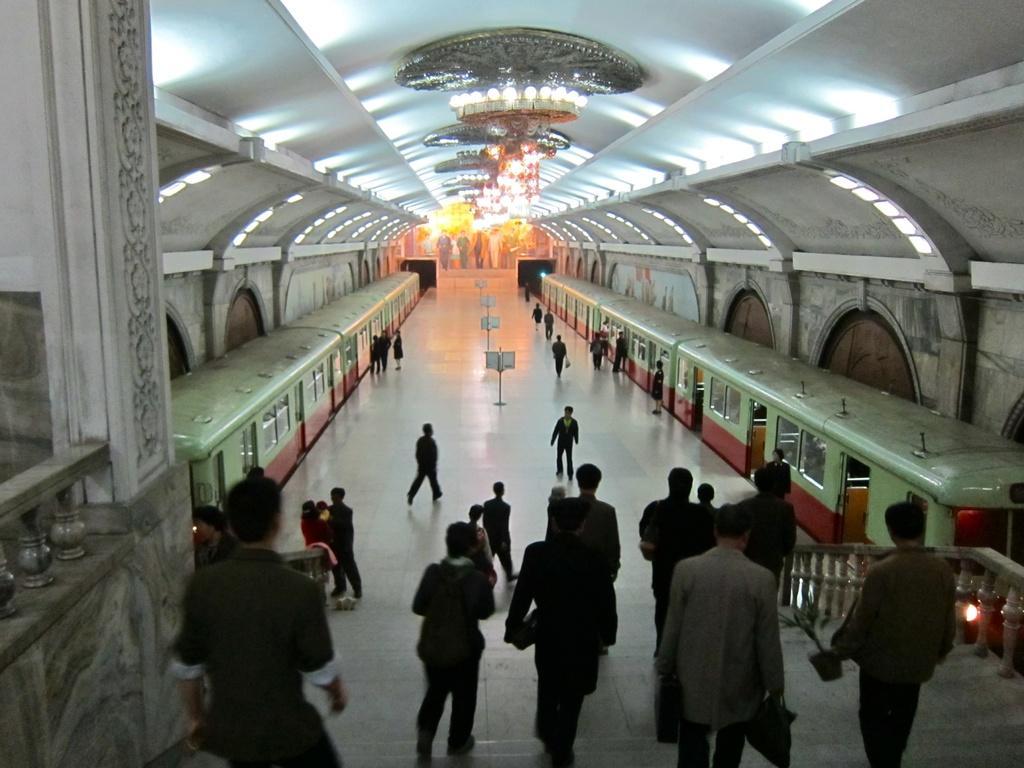Could you give a brief overview of what you see in this image? In this image, we can see people, trains, lights, boards and stairs. At the top, there is a roof and at the bottom, there is a floor. 